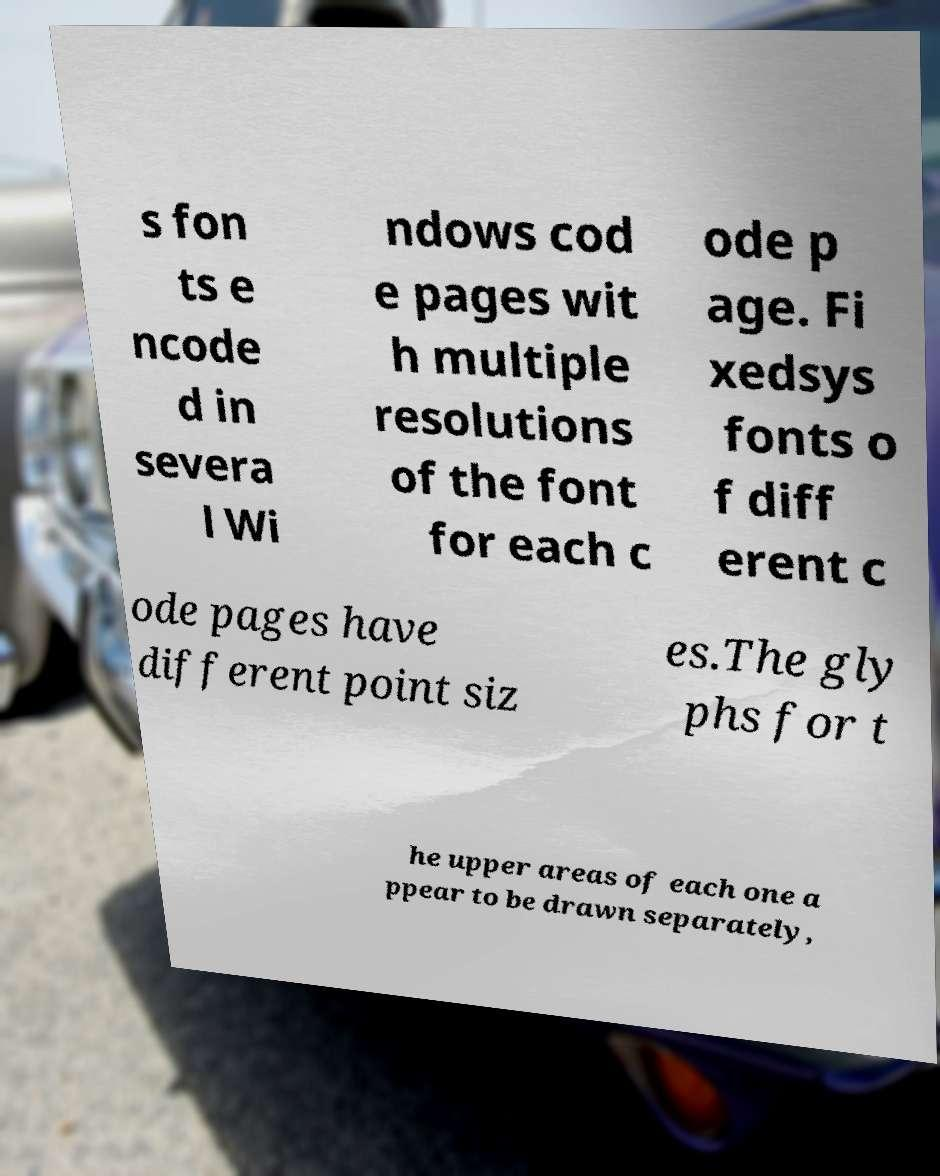For documentation purposes, I need the text within this image transcribed. Could you provide that? s fon ts e ncode d in severa l Wi ndows cod e pages wit h multiple resolutions of the font for each c ode p age. Fi xedsys fonts o f diff erent c ode pages have different point siz es.The gly phs for t he upper areas of each one a ppear to be drawn separately, 